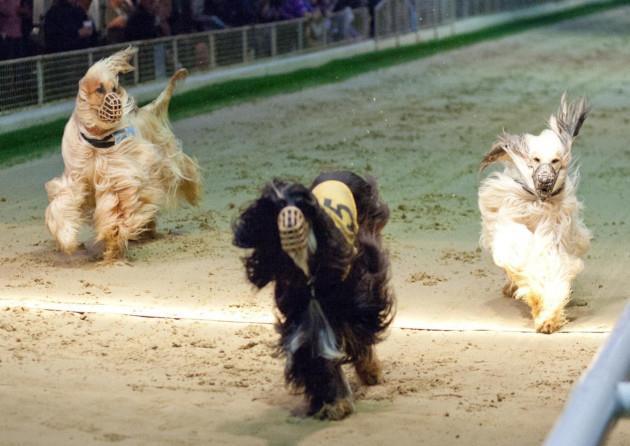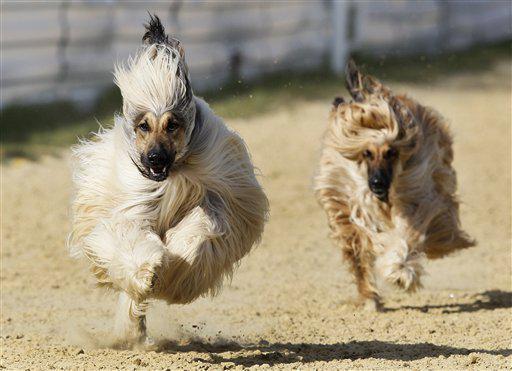The first image is the image on the left, the second image is the image on the right. For the images displayed, is the sentence "There are four dogs in total." factually correct? Answer yes or no. No. The first image is the image on the left, the second image is the image on the right. Given the left and right images, does the statement "The left and right image contains the same number of dogs." hold true? Answer yes or no. No. 